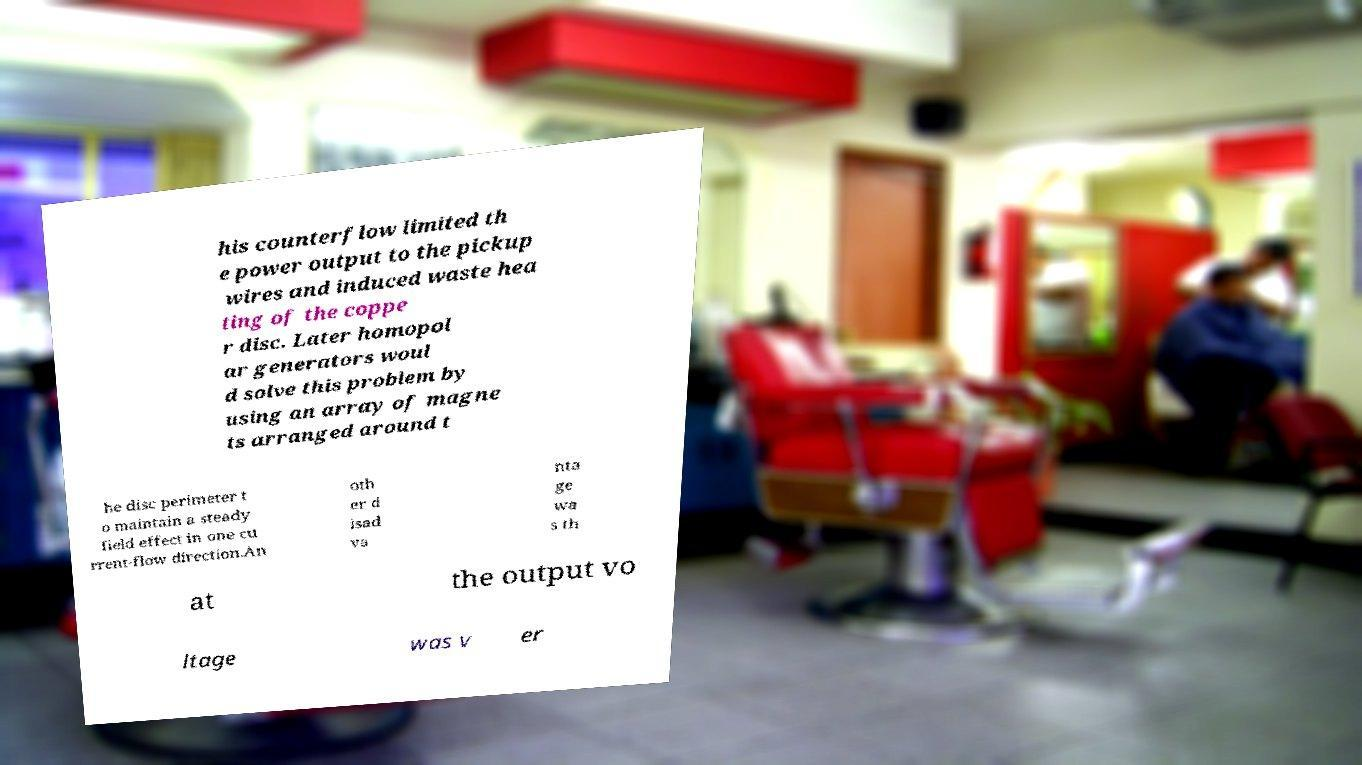Please identify and transcribe the text found in this image. his counterflow limited th e power output to the pickup wires and induced waste hea ting of the coppe r disc. Later homopol ar generators woul d solve this problem by using an array of magne ts arranged around t he disc perimeter t o maintain a steady field effect in one cu rrent-flow direction.An oth er d isad va nta ge wa s th at the output vo ltage was v er 